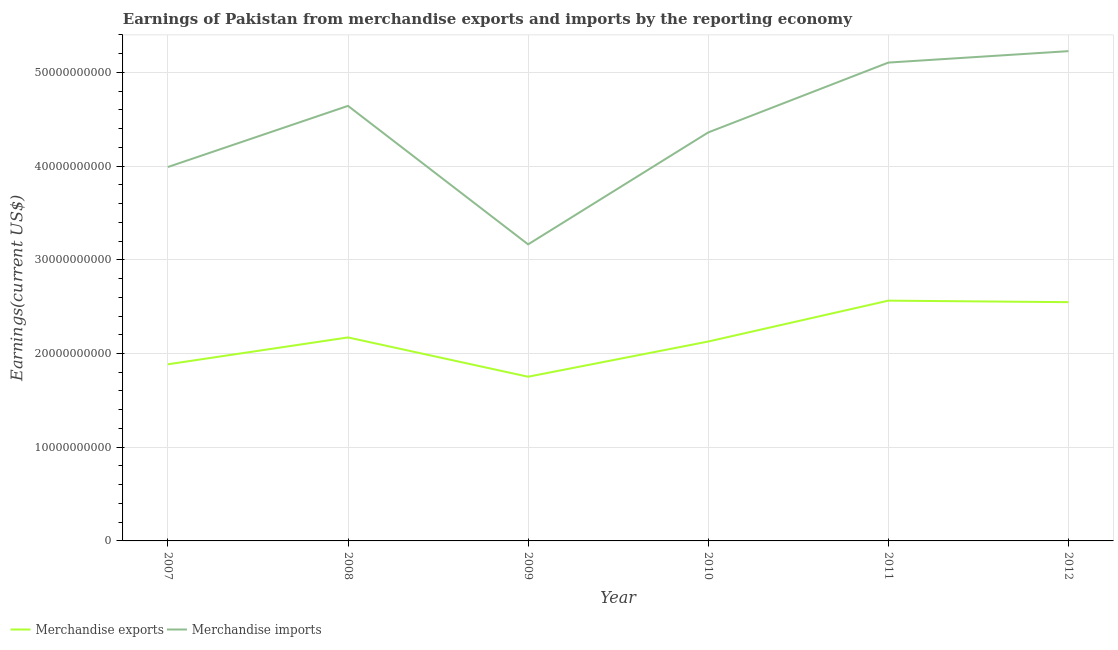How many different coloured lines are there?
Your response must be concise. 2. Does the line corresponding to earnings from merchandise imports intersect with the line corresponding to earnings from merchandise exports?
Give a very brief answer. No. Is the number of lines equal to the number of legend labels?
Give a very brief answer. Yes. What is the earnings from merchandise imports in 2007?
Offer a terse response. 3.99e+1. Across all years, what is the maximum earnings from merchandise imports?
Your answer should be compact. 5.23e+1. Across all years, what is the minimum earnings from merchandise imports?
Ensure brevity in your answer.  3.16e+1. In which year was the earnings from merchandise imports maximum?
Your response must be concise. 2012. In which year was the earnings from merchandise exports minimum?
Your answer should be compact. 2009. What is the total earnings from merchandise imports in the graph?
Keep it short and to the point. 2.65e+11. What is the difference between the earnings from merchandise imports in 2009 and that in 2011?
Your answer should be very brief. -1.94e+1. What is the difference between the earnings from merchandise exports in 2007 and the earnings from merchandise imports in 2009?
Give a very brief answer. -1.28e+1. What is the average earnings from merchandise exports per year?
Your answer should be compact. 2.17e+1. In the year 2008, what is the difference between the earnings from merchandise exports and earnings from merchandise imports?
Your answer should be compact. -2.47e+1. In how many years, is the earnings from merchandise imports greater than 14000000000 US$?
Offer a very short reply. 6. What is the ratio of the earnings from merchandise exports in 2007 to that in 2010?
Provide a succinct answer. 0.89. Is the difference between the earnings from merchandise imports in 2007 and 2009 greater than the difference between the earnings from merchandise exports in 2007 and 2009?
Provide a succinct answer. Yes. What is the difference between the highest and the second highest earnings from merchandise exports?
Provide a short and direct response. 1.62e+08. What is the difference between the highest and the lowest earnings from merchandise imports?
Your answer should be compact. 2.06e+1. Is the sum of the earnings from merchandise exports in 2007 and 2009 greater than the maximum earnings from merchandise imports across all years?
Give a very brief answer. No. Does the earnings from merchandise imports monotonically increase over the years?
Offer a very short reply. No. Is the earnings from merchandise exports strictly less than the earnings from merchandise imports over the years?
Your answer should be compact. Yes. What is the difference between two consecutive major ticks on the Y-axis?
Keep it short and to the point. 1.00e+1. Are the values on the major ticks of Y-axis written in scientific E-notation?
Give a very brief answer. No. Does the graph contain any zero values?
Offer a terse response. No. How many legend labels are there?
Your response must be concise. 2. How are the legend labels stacked?
Your answer should be compact. Horizontal. What is the title of the graph?
Give a very brief answer. Earnings of Pakistan from merchandise exports and imports by the reporting economy. What is the label or title of the Y-axis?
Your answer should be very brief. Earnings(current US$). What is the Earnings(current US$) in Merchandise exports in 2007?
Offer a terse response. 1.88e+1. What is the Earnings(current US$) in Merchandise imports in 2007?
Provide a short and direct response. 3.99e+1. What is the Earnings(current US$) of Merchandise exports in 2008?
Offer a terse response. 2.17e+1. What is the Earnings(current US$) of Merchandise imports in 2008?
Your answer should be very brief. 4.64e+1. What is the Earnings(current US$) in Merchandise exports in 2009?
Your answer should be very brief. 1.75e+1. What is the Earnings(current US$) in Merchandise imports in 2009?
Your answer should be very brief. 3.16e+1. What is the Earnings(current US$) of Merchandise exports in 2010?
Provide a short and direct response. 2.13e+1. What is the Earnings(current US$) of Merchandise imports in 2010?
Give a very brief answer. 4.36e+1. What is the Earnings(current US$) in Merchandise exports in 2011?
Keep it short and to the point. 2.56e+1. What is the Earnings(current US$) in Merchandise imports in 2011?
Ensure brevity in your answer.  5.10e+1. What is the Earnings(current US$) of Merchandise exports in 2012?
Make the answer very short. 2.55e+1. What is the Earnings(current US$) in Merchandise imports in 2012?
Your response must be concise. 5.23e+1. Across all years, what is the maximum Earnings(current US$) of Merchandise exports?
Ensure brevity in your answer.  2.56e+1. Across all years, what is the maximum Earnings(current US$) of Merchandise imports?
Keep it short and to the point. 5.23e+1. Across all years, what is the minimum Earnings(current US$) of Merchandise exports?
Make the answer very short. 1.75e+1. Across all years, what is the minimum Earnings(current US$) in Merchandise imports?
Make the answer very short. 3.16e+1. What is the total Earnings(current US$) in Merchandise exports in the graph?
Provide a succinct answer. 1.30e+11. What is the total Earnings(current US$) of Merchandise imports in the graph?
Give a very brief answer. 2.65e+11. What is the difference between the Earnings(current US$) in Merchandise exports in 2007 and that in 2008?
Offer a terse response. -2.87e+09. What is the difference between the Earnings(current US$) in Merchandise imports in 2007 and that in 2008?
Your answer should be compact. -6.53e+09. What is the difference between the Earnings(current US$) of Merchandise exports in 2007 and that in 2009?
Your answer should be compact. 1.33e+09. What is the difference between the Earnings(current US$) of Merchandise imports in 2007 and that in 2009?
Offer a terse response. 8.25e+09. What is the difference between the Earnings(current US$) of Merchandise exports in 2007 and that in 2010?
Your answer should be very brief. -2.43e+09. What is the difference between the Earnings(current US$) of Merchandise imports in 2007 and that in 2010?
Your answer should be very brief. -3.69e+09. What is the difference between the Earnings(current US$) of Merchandise exports in 2007 and that in 2011?
Offer a terse response. -6.79e+09. What is the difference between the Earnings(current US$) in Merchandise imports in 2007 and that in 2011?
Provide a succinct answer. -1.11e+1. What is the difference between the Earnings(current US$) in Merchandise exports in 2007 and that in 2012?
Provide a succinct answer. -6.63e+09. What is the difference between the Earnings(current US$) of Merchandise imports in 2007 and that in 2012?
Give a very brief answer. -1.24e+1. What is the difference between the Earnings(current US$) of Merchandise exports in 2008 and that in 2009?
Your response must be concise. 4.19e+09. What is the difference between the Earnings(current US$) in Merchandise imports in 2008 and that in 2009?
Offer a very short reply. 1.48e+1. What is the difference between the Earnings(current US$) of Merchandise exports in 2008 and that in 2010?
Ensure brevity in your answer.  4.37e+08. What is the difference between the Earnings(current US$) in Merchandise imports in 2008 and that in 2010?
Ensure brevity in your answer.  2.83e+09. What is the difference between the Earnings(current US$) in Merchandise exports in 2008 and that in 2011?
Provide a succinct answer. -3.93e+09. What is the difference between the Earnings(current US$) in Merchandise imports in 2008 and that in 2011?
Ensure brevity in your answer.  -4.62e+09. What is the difference between the Earnings(current US$) in Merchandise exports in 2008 and that in 2012?
Give a very brief answer. -3.76e+09. What is the difference between the Earnings(current US$) in Merchandise imports in 2008 and that in 2012?
Offer a very short reply. -5.84e+09. What is the difference between the Earnings(current US$) of Merchandise exports in 2009 and that in 2010?
Offer a very short reply. -3.76e+09. What is the difference between the Earnings(current US$) in Merchandise imports in 2009 and that in 2010?
Ensure brevity in your answer.  -1.19e+1. What is the difference between the Earnings(current US$) of Merchandise exports in 2009 and that in 2011?
Offer a very short reply. -8.12e+09. What is the difference between the Earnings(current US$) in Merchandise imports in 2009 and that in 2011?
Provide a short and direct response. -1.94e+1. What is the difference between the Earnings(current US$) of Merchandise exports in 2009 and that in 2012?
Provide a succinct answer. -7.96e+09. What is the difference between the Earnings(current US$) in Merchandise imports in 2009 and that in 2012?
Your answer should be compact. -2.06e+1. What is the difference between the Earnings(current US$) in Merchandise exports in 2010 and that in 2011?
Give a very brief answer. -4.36e+09. What is the difference between the Earnings(current US$) of Merchandise imports in 2010 and that in 2011?
Make the answer very short. -7.45e+09. What is the difference between the Earnings(current US$) of Merchandise exports in 2010 and that in 2012?
Offer a terse response. -4.20e+09. What is the difference between the Earnings(current US$) of Merchandise imports in 2010 and that in 2012?
Make the answer very short. -8.67e+09. What is the difference between the Earnings(current US$) in Merchandise exports in 2011 and that in 2012?
Your answer should be compact. 1.62e+08. What is the difference between the Earnings(current US$) of Merchandise imports in 2011 and that in 2012?
Provide a short and direct response. -1.22e+09. What is the difference between the Earnings(current US$) in Merchandise exports in 2007 and the Earnings(current US$) in Merchandise imports in 2008?
Give a very brief answer. -2.76e+1. What is the difference between the Earnings(current US$) of Merchandise exports in 2007 and the Earnings(current US$) of Merchandise imports in 2009?
Your answer should be compact. -1.28e+1. What is the difference between the Earnings(current US$) of Merchandise exports in 2007 and the Earnings(current US$) of Merchandise imports in 2010?
Offer a very short reply. -2.47e+1. What is the difference between the Earnings(current US$) in Merchandise exports in 2007 and the Earnings(current US$) in Merchandise imports in 2011?
Offer a terse response. -3.22e+1. What is the difference between the Earnings(current US$) in Merchandise exports in 2007 and the Earnings(current US$) in Merchandise imports in 2012?
Offer a very short reply. -3.34e+1. What is the difference between the Earnings(current US$) in Merchandise exports in 2008 and the Earnings(current US$) in Merchandise imports in 2009?
Make the answer very short. -9.93e+09. What is the difference between the Earnings(current US$) in Merchandise exports in 2008 and the Earnings(current US$) in Merchandise imports in 2010?
Make the answer very short. -2.19e+1. What is the difference between the Earnings(current US$) of Merchandise exports in 2008 and the Earnings(current US$) of Merchandise imports in 2011?
Your answer should be very brief. -2.93e+1. What is the difference between the Earnings(current US$) of Merchandise exports in 2008 and the Earnings(current US$) of Merchandise imports in 2012?
Provide a short and direct response. -3.06e+1. What is the difference between the Earnings(current US$) in Merchandise exports in 2009 and the Earnings(current US$) in Merchandise imports in 2010?
Ensure brevity in your answer.  -2.61e+1. What is the difference between the Earnings(current US$) in Merchandise exports in 2009 and the Earnings(current US$) in Merchandise imports in 2011?
Your answer should be very brief. -3.35e+1. What is the difference between the Earnings(current US$) in Merchandise exports in 2009 and the Earnings(current US$) in Merchandise imports in 2012?
Provide a succinct answer. -3.47e+1. What is the difference between the Earnings(current US$) of Merchandise exports in 2010 and the Earnings(current US$) of Merchandise imports in 2011?
Offer a terse response. -2.98e+1. What is the difference between the Earnings(current US$) of Merchandise exports in 2010 and the Earnings(current US$) of Merchandise imports in 2012?
Your response must be concise. -3.10e+1. What is the difference between the Earnings(current US$) of Merchandise exports in 2011 and the Earnings(current US$) of Merchandise imports in 2012?
Give a very brief answer. -2.66e+1. What is the average Earnings(current US$) of Merchandise exports per year?
Provide a succinct answer. 2.17e+1. What is the average Earnings(current US$) of Merchandise imports per year?
Give a very brief answer. 4.41e+1. In the year 2007, what is the difference between the Earnings(current US$) of Merchandise exports and Earnings(current US$) of Merchandise imports?
Your answer should be very brief. -2.11e+1. In the year 2008, what is the difference between the Earnings(current US$) of Merchandise exports and Earnings(current US$) of Merchandise imports?
Provide a short and direct response. -2.47e+1. In the year 2009, what is the difference between the Earnings(current US$) of Merchandise exports and Earnings(current US$) of Merchandise imports?
Your answer should be compact. -1.41e+1. In the year 2010, what is the difference between the Earnings(current US$) of Merchandise exports and Earnings(current US$) of Merchandise imports?
Make the answer very short. -2.23e+1. In the year 2011, what is the difference between the Earnings(current US$) in Merchandise exports and Earnings(current US$) in Merchandise imports?
Ensure brevity in your answer.  -2.54e+1. In the year 2012, what is the difference between the Earnings(current US$) of Merchandise exports and Earnings(current US$) of Merchandise imports?
Make the answer very short. -2.68e+1. What is the ratio of the Earnings(current US$) of Merchandise exports in 2007 to that in 2008?
Your answer should be compact. 0.87. What is the ratio of the Earnings(current US$) of Merchandise imports in 2007 to that in 2008?
Keep it short and to the point. 0.86. What is the ratio of the Earnings(current US$) of Merchandise exports in 2007 to that in 2009?
Keep it short and to the point. 1.08. What is the ratio of the Earnings(current US$) in Merchandise imports in 2007 to that in 2009?
Make the answer very short. 1.26. What is the ratio of the Earnings(current US$) in Merchandise exports in 2007 to that in 2010?
Provide a short and direct response. 0.89. What is the ratio of the Earnings(current US$) in Merchandise imports in 2007 to that in 2010?
Your answer should be compact. 0.92. What is the ratio of the Earnings(current US$) in Merchandise exports in 2007 to that in 2011?
Offer a very short reply. 0.74. What is the ratio of the Earnings(current US$) of Merchandise imports in 2007 to that in 2011?
Your answer should be very brief. 0.78. What is the ratio of the Earnings(current US$) of Merchandise exports in 2007 to that in 2012?
Offer a very short reply. 0.74. What is the ratio of the Earnings(current US$) in Merchandise imports in 2007 to that in 2012?
Make the answer very short. 0.76. What is the ratio of the Earnings(current US$) of Merchandise exports in 2008 to that in 2009?
Your response must be concise. 1.24. What is the ratio of the Earnings(current US$) in Merchandise imports in 2008 to that in 2009?
Ensure brevity in your answer.  1.47. What is the ratio of the Earnings(current US$) of Merchandise exports in 2008 to that in 2010?
Provide a short and direct response. 1.02. What is the ratio of the Earnings(current US$) of Merchandise imports in 2008 to that in 2010?
Your response must be concise. 1.06. What is the ratio of the Earnings(current US$) of Merchandise exports in 2008 to that in 2011?
Offer a terse response. 0.85. What is the ratio of the Earnings(current US$) of Merchandise imports in 2008 to that in 2011?
Provide a short and direct response. 0.91. What is the ratio of the Earnings(current US$) of Merchandise exports in 2008 to that in 2012?
Offer a very short reply. 0.85. What is the ratio of the Earnings(current US$) of Merchandise imports in 2008 to that in 2012?
Provide a short and direct response. 0.89. What is the ratio of the Earnings(current US$) in Merchandise exports in 2009 to that in 2010?
Keep it short and to the point. 0.82. What is the ratio of the Earnings(current US$) of Merchandise imports in 2009 to that in 2010?
Your answer should be very brief. 0.73. What is the ratio of the Earnings(current US$) in Merchandise exports in 2009 to that in 2011?
Provide a short and direct response. 0.68. What is the ratio of the Earnings(current US$) of Merchandise imports in 2009 to that in 2011?
Keep it short and to the point. 0.62. What is the ratio of the Earnings(current US$) in Merchandise exports in 2009 to that in 2012?
Ensure brevity in your answer.  0.69. What is the ratio of the Earnings(current US$) of Merchandise imports in 2009 to that in 2012?
Your response must be concise. 0.61. What is the ratio of the Earnings(current US$) in Merchandise exports in 2010 to that in 2011?
Give a very brief answer. 0.83. What is the ratio of the Earnings(current US$) in Merchandise imports in 2010 to that in 2011?
Keep it short and to the point. 0.85. What is the ratio of the Earnings(current US$) of Merchandise exports in 2010 to that in 2012?
Keep it short and to the point. 0.84. What is the ratio of the Earnings(current US$) in Merchandise imports in 2010 to that in 2012?
Keep it short and to the point. 0.83. What is the ratio of the Earnings(current US$) of Merchandise exports in 2011 to that in 2012?
Provide a succinct answer. 1.01. What is the ratio of the Earnings(current US$) in Merchandise imports in 2011 to that in 2012?
Keep it short and to the point. 0.98. What is the difference between the highest and the second highest Earnings(current US$) in Merchandise exports?
Give a very brief answer. 1.62e+08. What is the difference between the highest and the second highest Earnings(current US$) of Merchandise imports?
Give a very brief answer. 1.22e+09. What is the difference between the highest and the lowest Earnings(current US$) of Merchandise exports?
Provide a short and direct response. 8.12e+09. What is the difference between the highest and the lowest Earnings(current US$) of Merchandise imports?
Offer a terse response. 2.06e+1. 